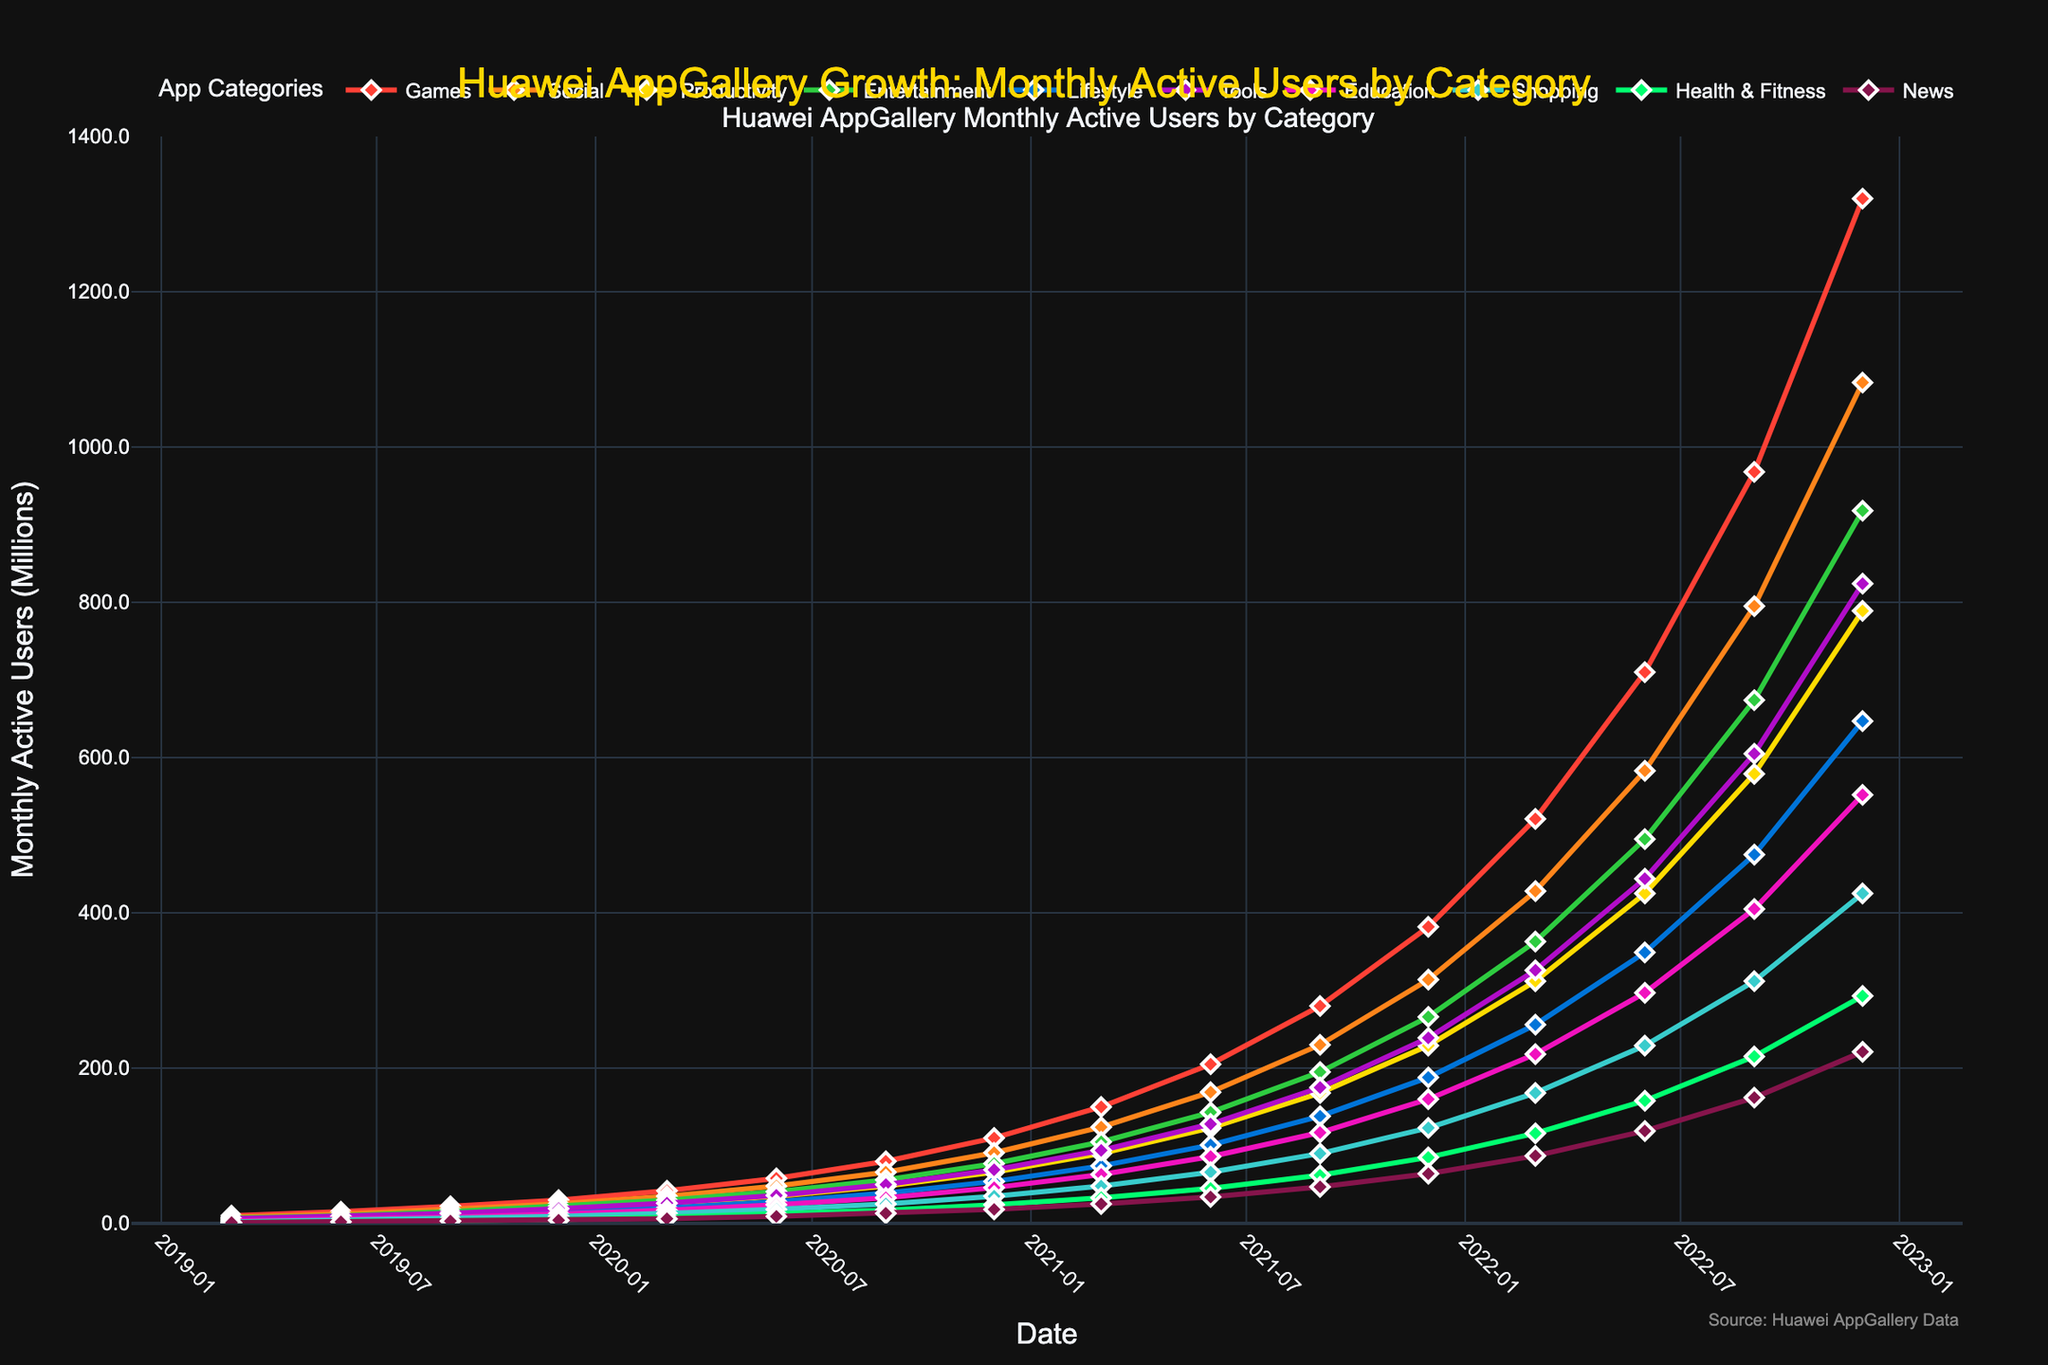Which app category had the highest number of monthly active users in December 2022? The highest point on the y-axis in December 2022 corresponds to the "Games" category. The point indicates 1320 million users.
Answer: Games What is the difference in monthly active users between the "Games" and "Tools" categories in September 2022? For September 2022, "Games" had 968 million users, and "Tools" had 605 million users. The difference is 968 - 605 = 363 million users.
Answer: 363 million Which two app categories had the closest number of monthly active users in June 2021, and what is the difference? In June 2021, "Health & Fitness" had 45 million users and "News" had 34 million users. The difference between these two categories is 45 - 34 = 11 million users.
Answer: Health & Fitness and News, 11 million What were the monthly active users for the "Education" category in March 2021? The line for the "Education" category in March 2021 reads 63 million users.
Answer: 63 million Between March 2022 and June 2022, which app category had the highest growth in monthly active users? Calculate the difference between March 2022 and June 2022 for all categories. "Games" grew from 521 to 710 million users. The increase is 710 - 521 = 189 million users, which is the highest among the categories.
Answer: Games Which app category saw a consistent increase in monthly active users across all given periods? All categories demonstrate an upward trend with no decline across the entire period from March 2019 to December 2022. To see this, reference each category line that continually increases without any dips.
Answer: All categories How did the monthly active users for the "Shopping" category change from December 2019 to December 2022? In December 2019, "Shopping" had 9 million users. By December 2022, it increased to 425 million users. The change is 425 - 9 = 416 million users.
Answer: 416 million What is the average number of monthly active users for the "Lifestyle" category across all time points? Add the "Lifestyle" values at all time points, then divide by the number of time points. (4+6+9+14+20+28+39+54+74+101+138+188+256+349+475+647)/16 = 1434/16 ≈ 89.625 million users.
Answer: 89.625 million Among the app categories "Health & Fitness" and "Education," which one had more monthly active users in December 2022, and by how much? In December 2022, "Health & Fitness" had 293 million users, and "Education" had 552 million users. The difference is 552 - 293 = 259 million users with "Education" being higher.
Answer: Education, 259 million 